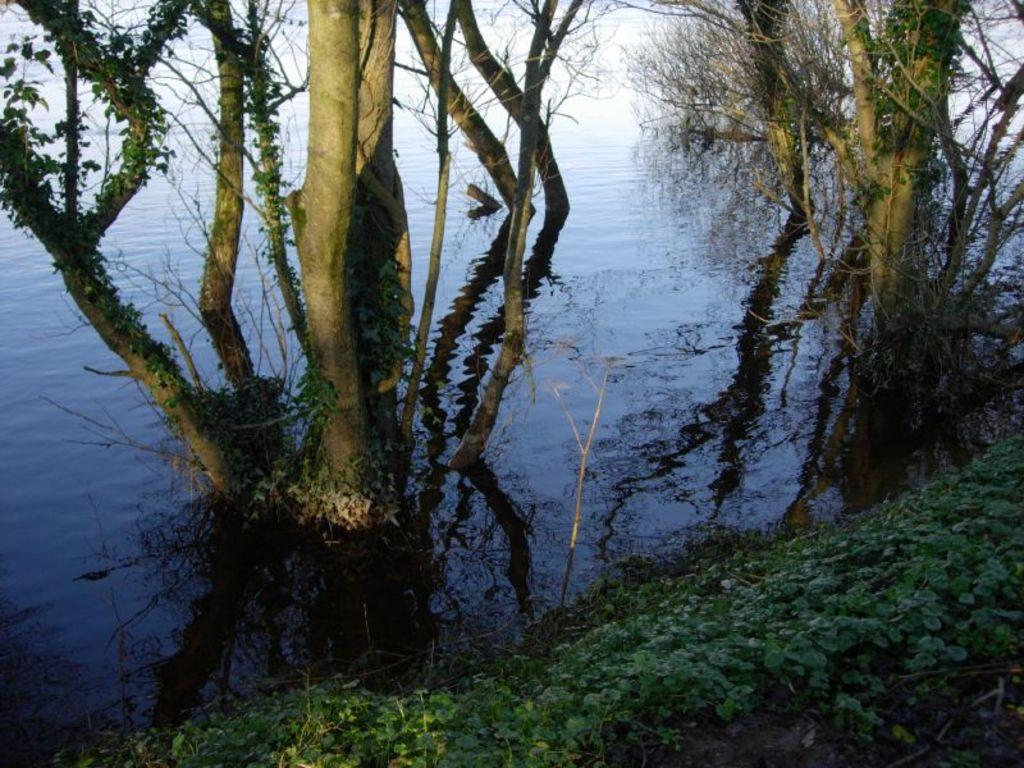What type of vegetation is present at the bottom of the image? There are plants at the bottom of the image. What can be seen in the center of the image? There are trees and a water body in the center of the image. Can you describe the water body in the image? The water body is located in the center of the image. What is visible in the background of the image? There is water visible in the background of the image. What type of suit is hanging on the tree in the image? There is no suit present in the image; it features plants, trees, and a water body. Can you tell me how many sheets of paper are floating on the water in the image? There are no sheets of paper present in the image; it only features plants, trees, and a water body. 